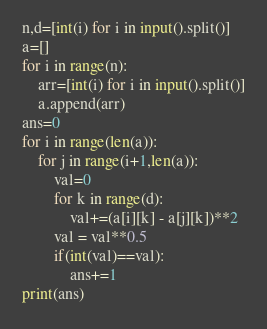Convert code to text. <code><loc_0><loc_0><loc_500><loc_500><_Python_>n,d=[int(i) for i in input().split()]
a=[]
for i in range(n):
    arr=[int(i) for i in input().split()]
    a.append(arr)
ans=0
for i in range(len(a)):
    for j in range(i+1,len(a)):
        val=0
        for k in range(d):
            val+=(a[i][k] - a[j][k])**2
        val = val**0.5
        if(int(val)==val):
            ans+=1
print(ans)
</code> 